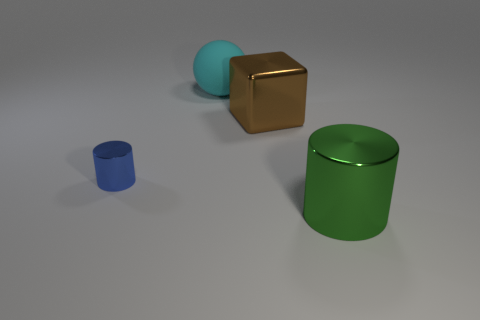What number of objects are big things in front of the big rubber object or metallic cylinders that are to the left of the cyan rubber ball?
Your answer should be very brief. 3. There is a cylinder that is in front of the metal cylinder that is behind the green metallic cylinder; what size is it?
Your answer should be compact. Large. What is the size of the blue metal object?
Offer a very short reply. Small. What number of other objects are there of the same material as the large green object?
Provide a succinct answer. 2. Are there any brown rubber cubes?
Keep it short and to the point. No. Is the material of the thing on the right side of the big brown shiny cube the same as the cyan thing?
Offer a very short reply. No. Is the number of brown cubes less than the number of brown cylinders?
Your response must be concise. No. There is another big thing that is the same material as the big brown thing; what color is it?
Provide a short and direct response. Green. Is the size of the brown object the same as the blue shiny object?
Make the answer very short. No. What is the material of the cyan ball?
Give a very brief answer. Rubber. 